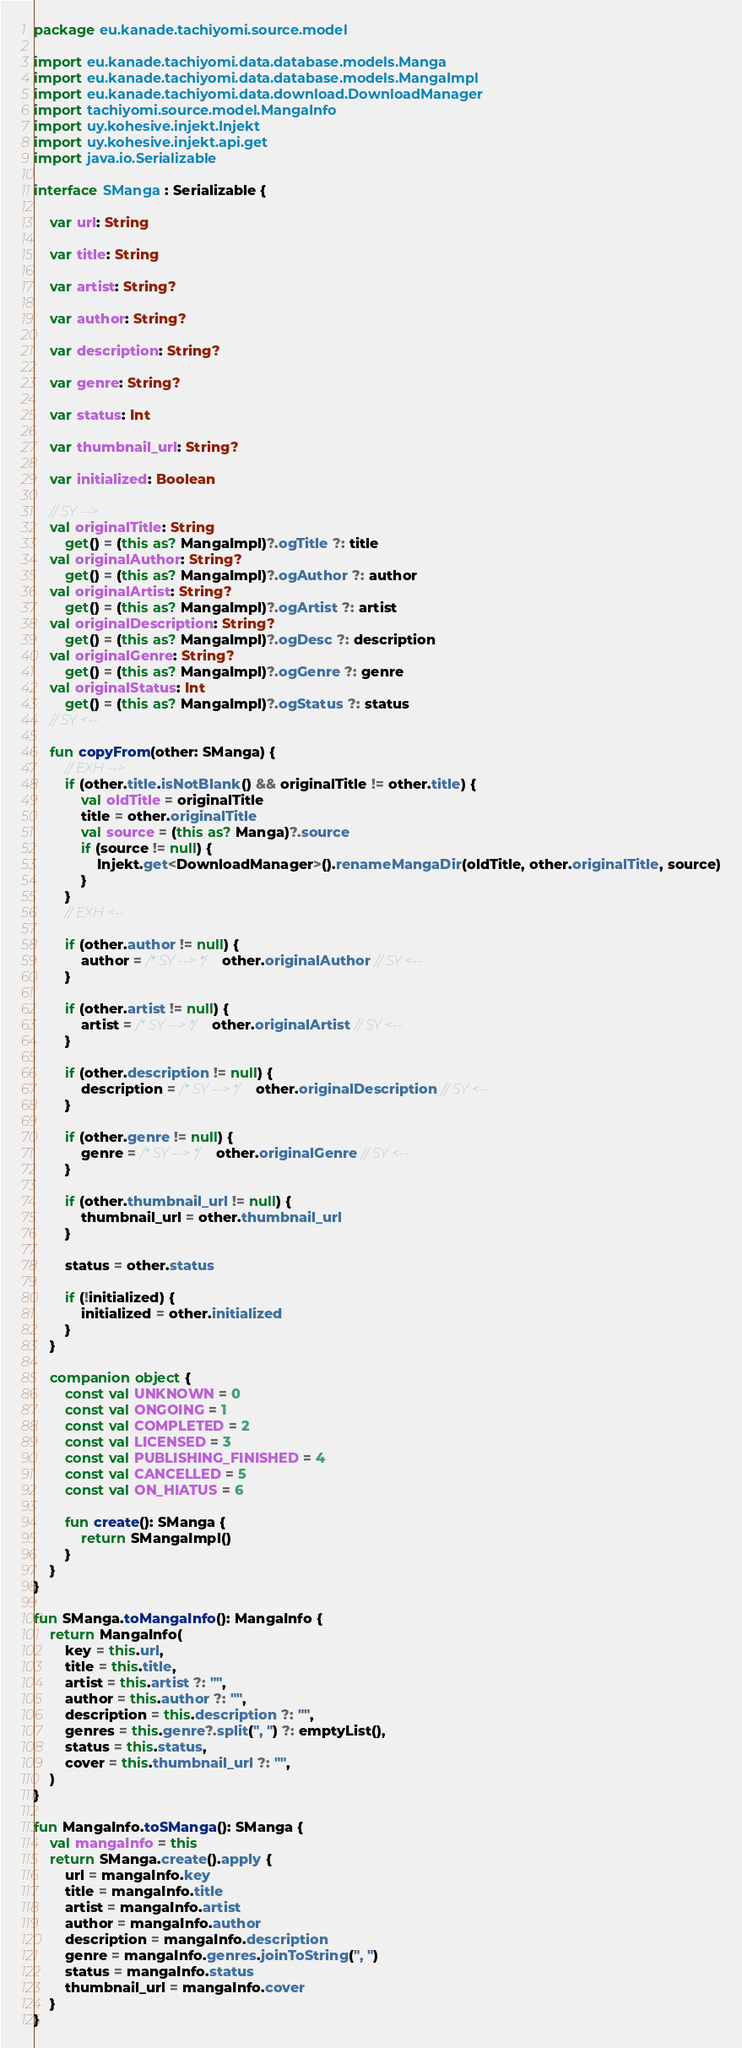Convert code to text. <code><loc_0><loc_0><loc_500><loc_500><_Kotlin_>package eu.kanade.tachiyomi.source.model

import eu.kanade.tachiyomi.data.database.models.Manga
import eu.kanade.tachiyomi.data.database.models.MangaImpl
import eu.kanade.tachiyomi.data.download.DownloadManager
import tachiyomi.source.model.MangaInfo
import uy.kohesive.injekt.Injekt
import uy.kohesive.injekt.api.get
import java.io.Serializable

interface SManga : Serializable {

    var url: String

    var title: String

    var artist: String?

    var author: String?

    var description: String?

    var genre: String?

    var status: Int

    var thumbnail_url: String?

    var initialized: Boolean

    // SY -->
    val originalTitle: String
        get() = (this as? MangaImpl)?.ogTitle ?: title
    val originalAuthor: String?
        get() = (this as? MangaImpl)?.ogAuthor ?: author
    val originalArtist: String?
        get() = (this as? MangaImpl)?.ogArtist ?: artist
    val originalDescription: String?
        get() = (this as? MangaImpl)?.ogDesc ?: description
    val originalGenre: String?
        get() = (this as? MangaImpl)?.ogGenre ?: genre
    val originalStatus: Int
        get() = (this as? MangaImpl)?.ogStatus ?: status
    // SY <--

    fun copyFrom(other: SManga) {
        // EXH -->
        if (other.title.isNotBlank() && originalTitle != other.title) {
            val oldTitle = originalTitle
            title = other.originalTitle
            val source = (this as? Manga)?.source
            if (source != null) {
                Injekt.get<DownloadManager>().renameMangaDir(oldTitle, other.originalTitle, source)
            }
        }
        // EXH <--

        if (other.author != null) {
            author = /* SY --> */ other.originalAuthor // SY <--
        }

        if (other.artist != null) {
            artist = /* SY --> */ other.originalArtist // SY <--
        }

        if (other.description != null) {
            description = /* SY --> */ other.originalDescription // SY <--
        }

        if (other.genre != null) {
            genre = /* SY --> */ other.originalGenre // SY <--
        }

        if (other.thumbnail_url != null) {
            thumbnail_url = other.thumbnail_url
        }

        status = other.status

        if (!initialized) {
            initialized = other.initialized
        }
    }

    companion object {
        const val UNKNOWN = 0
        const val ONGOING = 1
        const val COMPLETED = 2
        const val LICENSED = 3
        const val PUBLISHING_FINISHED = 4
        const val CANCELLED = 5
        const val ON_HIATUS = 6

        fun create(): SManga {
            return SMangaImpl()
        }
    }
}

fun SManga.toMangaInfo(): MangaInfo {
    return MangaInfo(
        key = this.url,
        title = this.title,
        artist = this.artist ?: "",
        author = this.author ?: "",
        description = this.description ?: "",
        genres = this.genre?.split(", ") ?: emptyList(),
        status = this.status,
        cover = this.thumbnail_url ?: "",
    )
}

fun MangaInfo.toSManga(): SManga {
    val mangaInfo = this
    return SManga.create().apply {
        url = mangaInfo.key
        title = mangaInfo.title
        artist = mangaInfo.artist
        author = mangaInfo.author
        description = mangaInfo.description
        genre = mangaInfo.genres.joinToString(", ")
        status = mangaInfo.status
        thumbnail_url = mangaInfo.cover
    }
}
</code> 